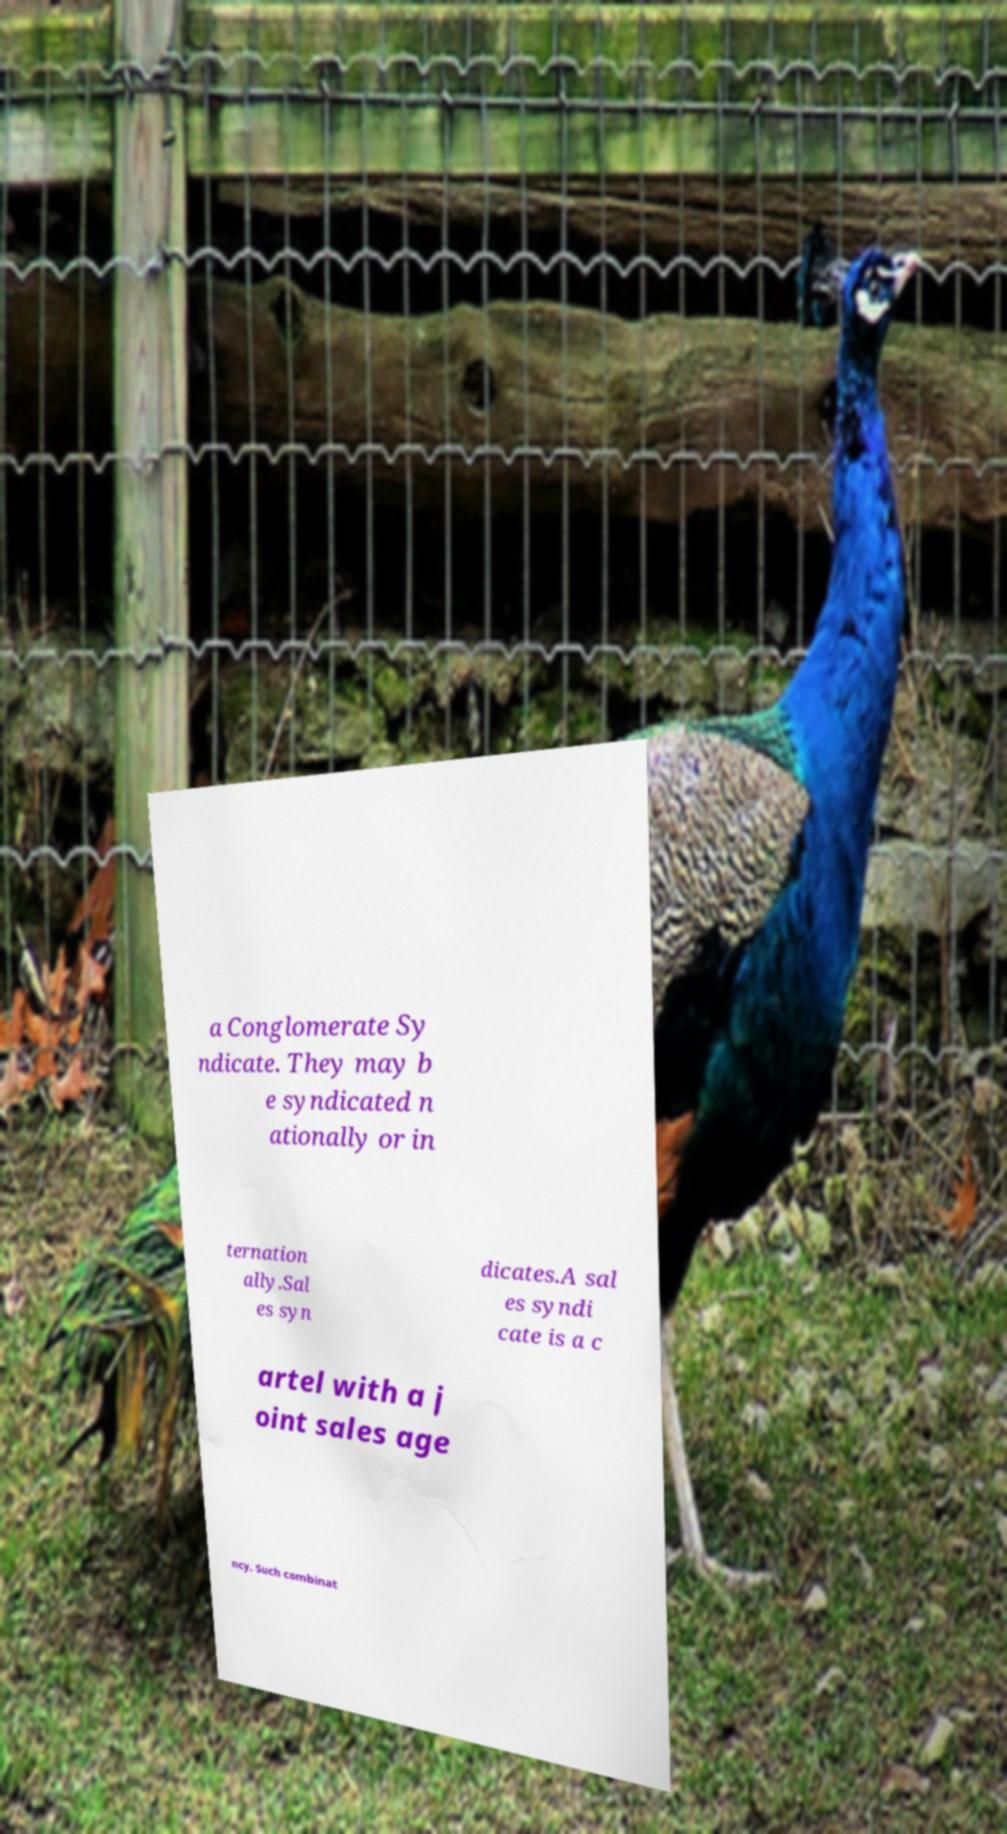Can you accurately transcribe the text from the provided image for me? a Conglomerate Sy ndicate. They may b e syndicated n ationally or in ternation ally.Sal es syn dicates.A sal es syndi cate is a c artel with a j oint sales age ncy. Such combinat 